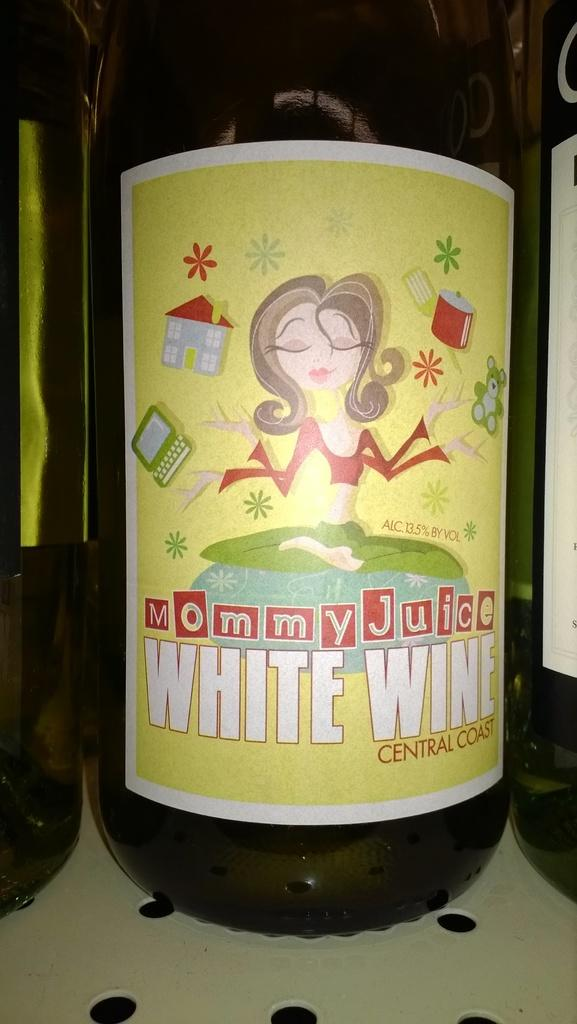Provide a one-sentence caption for the provided image. A bottle of Mommy Juice White Wine from the central coast. 